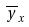Convert formula to latex. <formula><loc_0><loc_0><loc_500><loc_500>\overline { y } _ { x }</formula> 